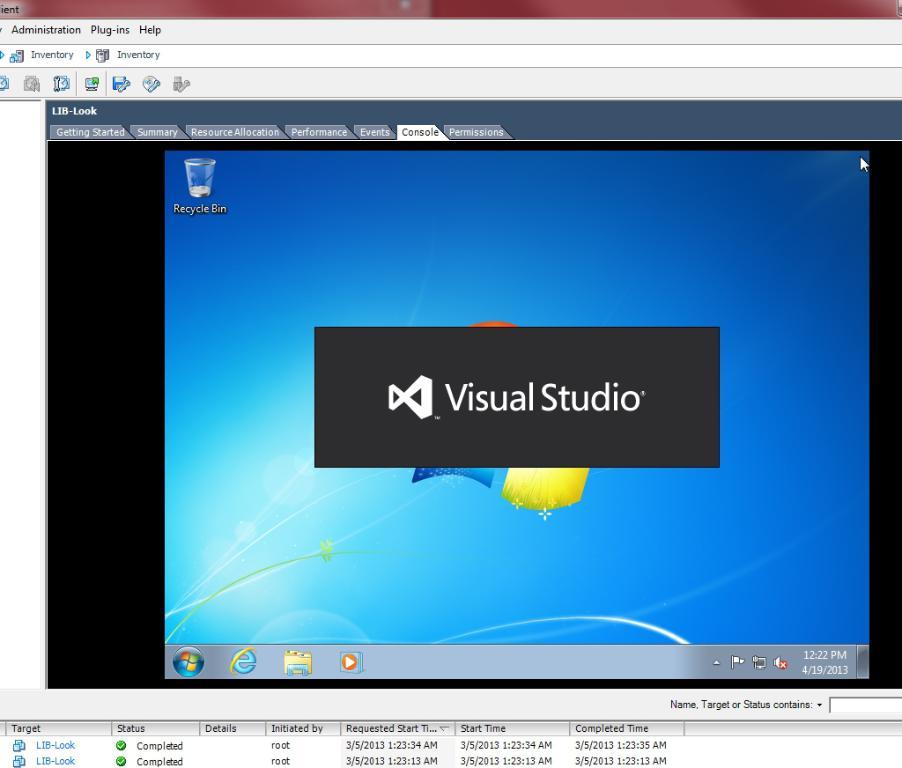<image>
Write a terse but informative summary of the picture. A close up of a computer monitor that says Visual Studio. 